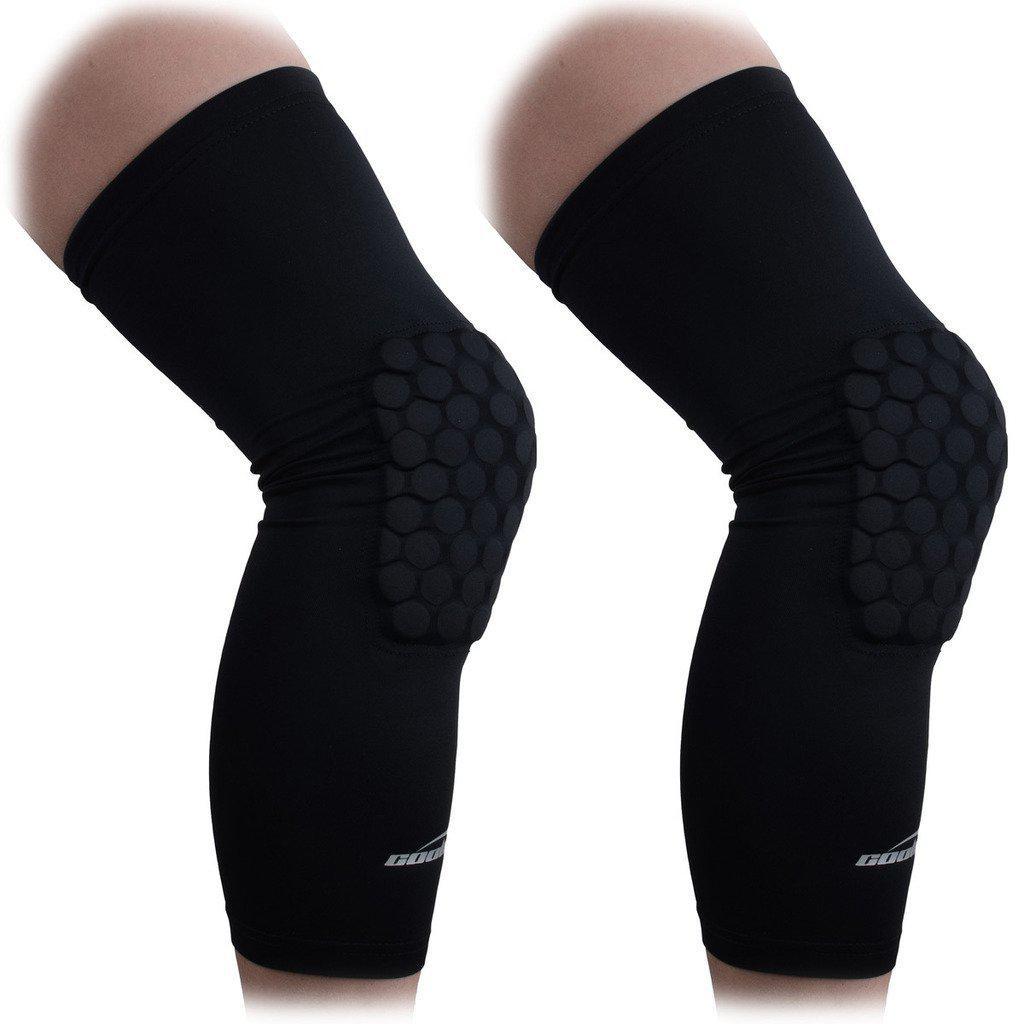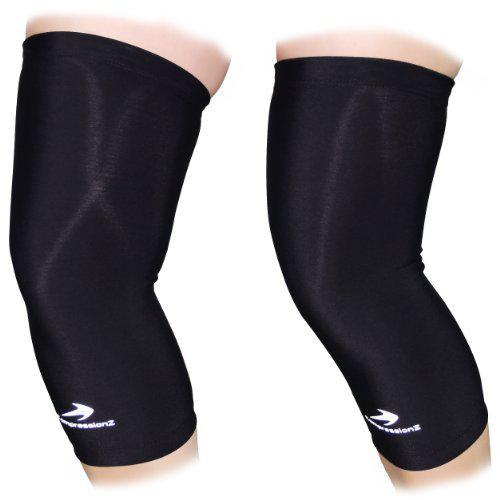The first image is the image on the left, the second image is the image on the right. Evaluate the accuracy of this statement regarding the images: "There are three knee braces in total.". Is it true? Answer yes or no. No. The first image is the image on the left, the second image is the image on the right. Examine the images to the left and right. Is the description "The left and right image contains a total of three knee pads." accurate? Answer yes or no. No. 